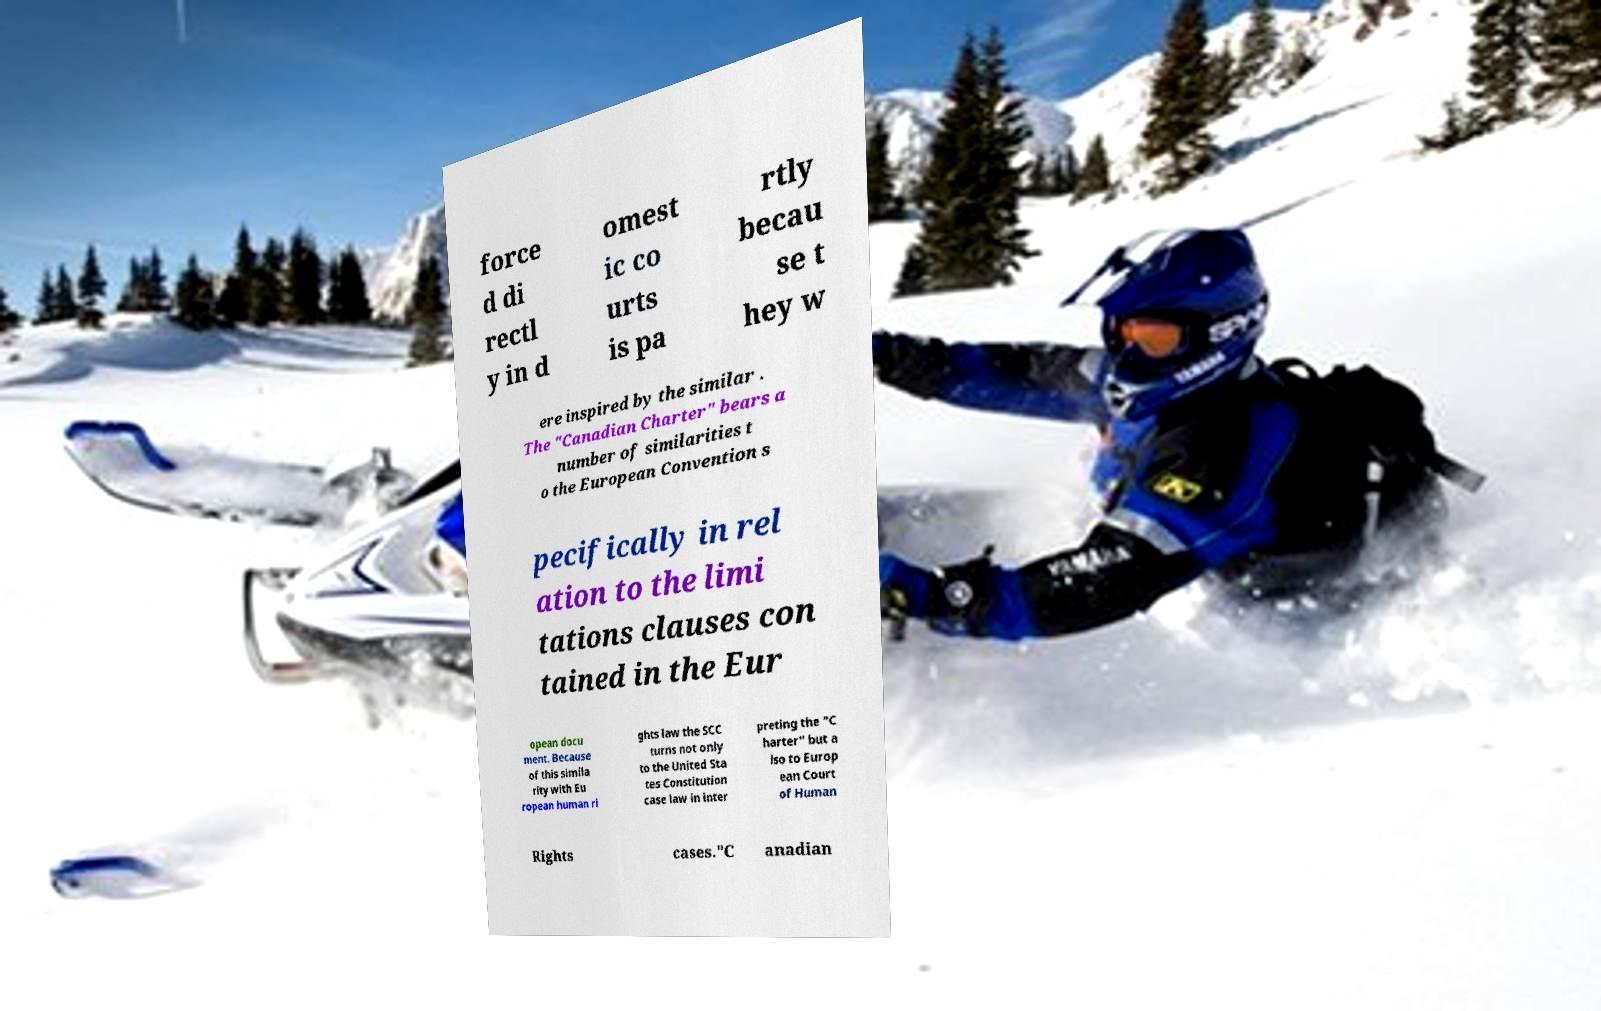Please read and relay the text visible in this image. What does it say? force d di rectl y in d omest ic co urts is pa rtly becau se t hey w ere inspired by the similar . The "Canadian Charter" bears a number of similarities t o the European Convention s pecifically in rel ation to the limi tations clauses con tained in the Eur opean docu ment. Because of this simila rity with Eu ropean human ri ghts law the SCC turns not only to the United Sta tes Constitution case law in inter preting the "C harter" but a lso to Europ ean Court of Human Rights cases."C anadian 